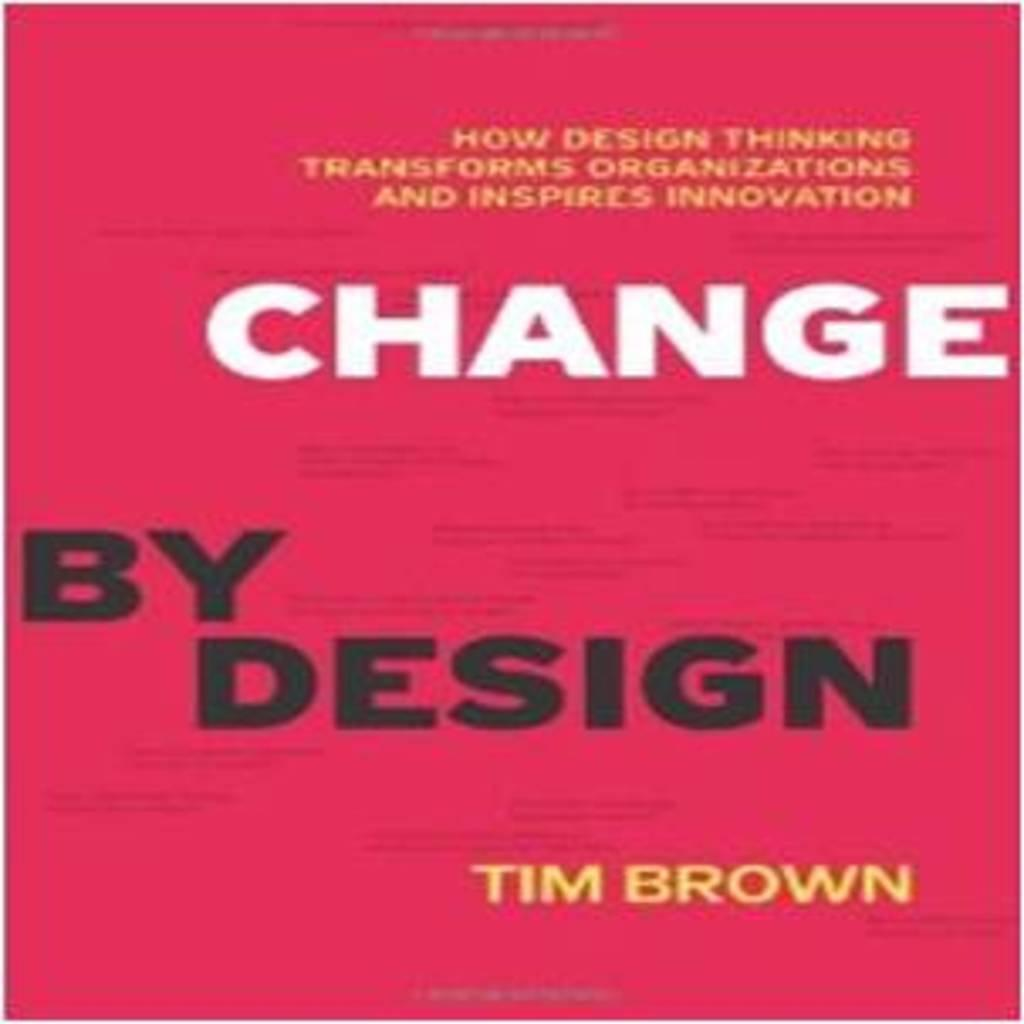<image>
Write a terse but informative summary of the picture. The cover of a book titled Change by Design is shown. 